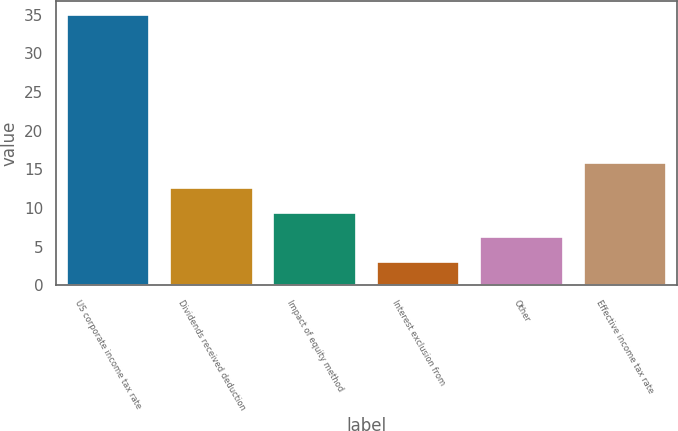Convert chart. <chart><loc_0><loc_0><loc_500><loc_500><bar_chart><fcel>US corporate income tax rate<fcel>Dividends received deduction<fcel>Impact of equity method<fcel>Interest exclusion from<fcel>Other<fcel>Effective income tax rate<nl><fcel>35<fcel>12.6<fcel>9.4<fcel>3<fcel>6.2<fcel>15.8<nl></chart> 